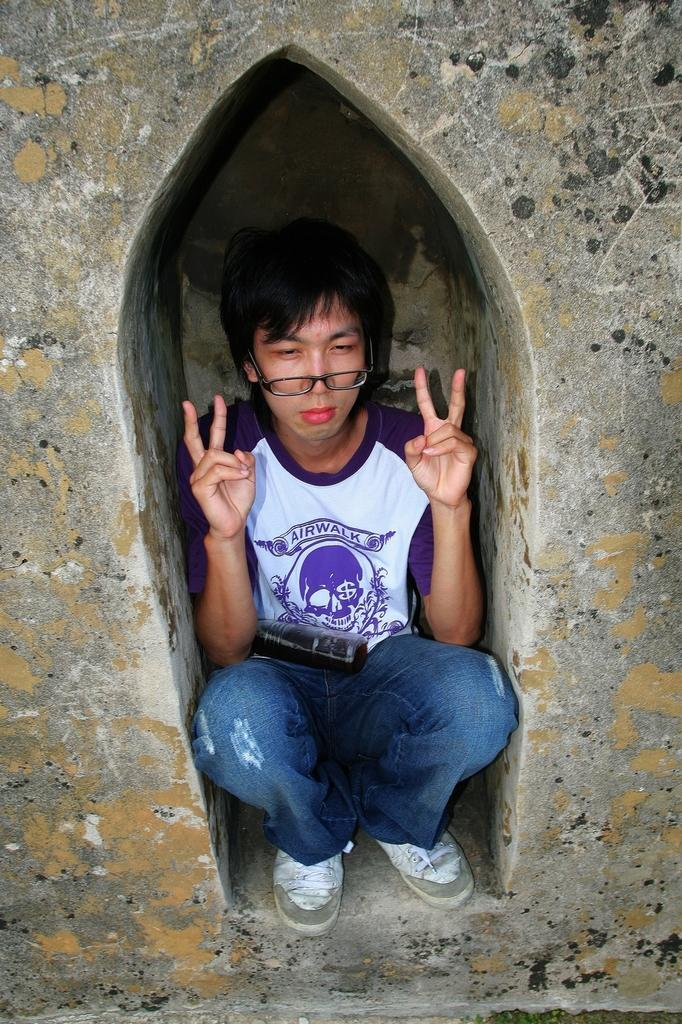Who or what is present in the image? There is a person in the image. What can be seen surrounding the person? There are walls in the image. Are there any ants crawling on the person in the image? There is no mention of ants in the image, so we cannot determine if there are any ants present. 